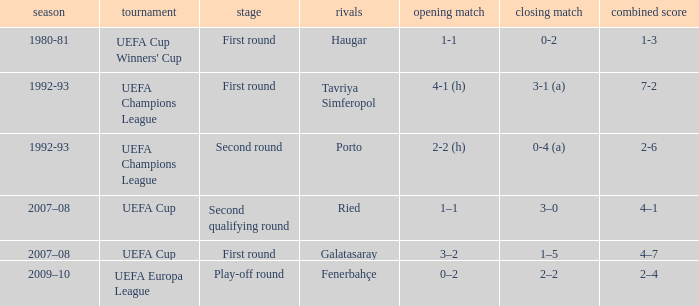Give me the full table as a dictionary. {'header': ['season', 'tournament', 'stage', 'rivals', 'opening match', 'closing match', 'combined score'], 'rows': [['1980-81', "UEFA Cup Winners' Cup", 'First round', 'Haugar', '1-1', '0-2', '1-3'], ['1992-93', 'UEFA Champions League', 'First round', 'Tavriya Simferopol', '4-1 (h)', '3-1 (a)', '7-2'], ['1992-93', 'UEFA Champions League', 'Second round', 'Porto', '2-2 (h)', '0-4 (a)', '2-6'], ['2007–08', 'UEFA Cup', 'Second qualifying round', 'Ried', '1–1', '3–0', '4–1'], ['2007–08', 'UEFA Cup', 'First round', 'Galatasaray', '3–2', '1–5', '4–7'], ['2009–10', 'UEFA Europa League', 'Play-off round', 'Fenerbahçe', '0–2', '2–2', '2–4']]} What is the total number of 2nd leg where aggregate is 7-2 1.0. 